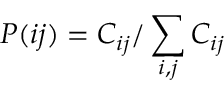<formula> <loc_0><loc_0><loc_500><loc_500>P ( i j ) = C _ { i j } / \sum _ { i , j } C _ { i j }</formula> 